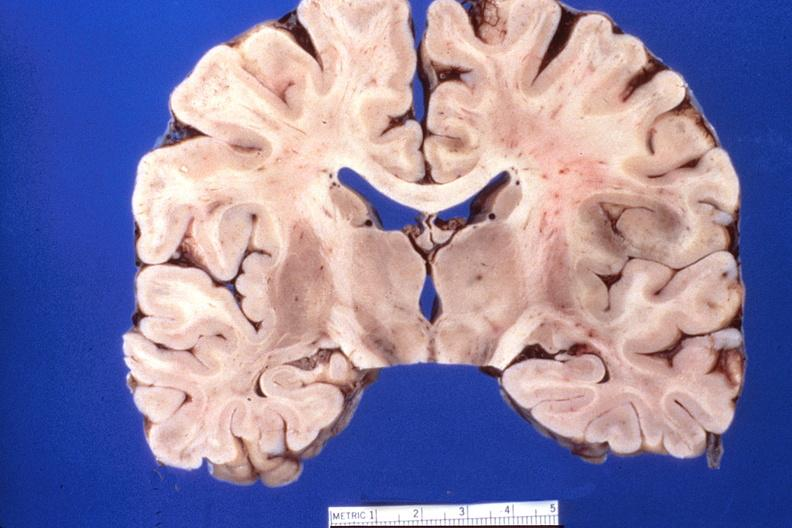what does this image show?
Answer the question using a single word or phrase. Brain 